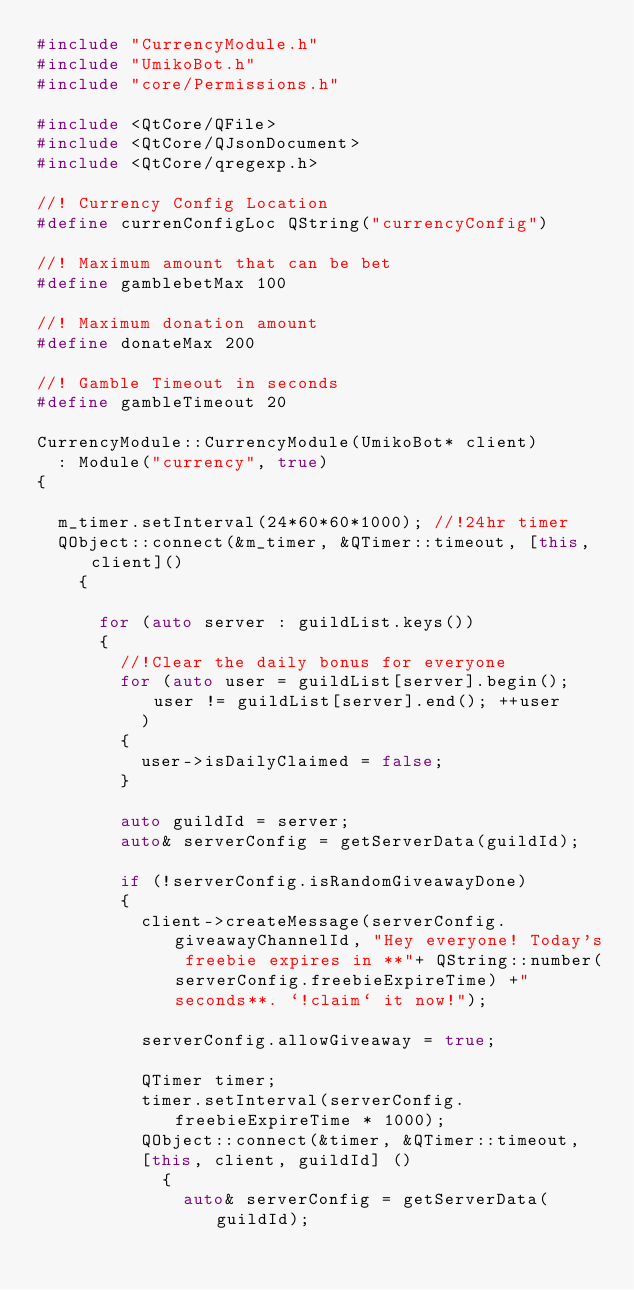<code> <loc_0><loc_0><loc_500><loc_500><_C++_>#include "CurrencyModule.h"
#include "UmikoBot.h"
#include "core/Permissions.h"

#include <QtCore/QFile>
#include <QtCore/QJsonDocument>
#include <QtCore/qregexp.h>

//! Currency Config Location
#define currenConfigLoc QString("currencyConfig")

//! Maximum amount that can be bet
#define gamblebetMax 100

//! Maximum donation amount
#define donateMax 200

//! Gamble Timeout in seconds
#define gambleTimeout 20

CurrencyModule::CurrencyModule(UmikoBot* client)
	: Module("currency", true)
{

	m_timer.setInterval(24*60*60*1000); //!24hr timer
	QObject::connect(&m_timer, &QTimer::timeout, [this, client]() 
		{
			
			for (auto server : guildList.keys()) 
			{
				//!Clear the daily bonus for everyone
				for (auto user = guildList[server].begin(); user != guildList[server].end(); ++user
					) 
				{
					user->isDailyClaimed = false;
				}

				auto guildId = server;
				auto& serverConfig = getServerData(guildId);

				if (!serverConfig.isRandomGiveawayDone) 
				{
					client->createMessage(serverConfig.giveawayChannelId, "Hey everyone! Today's freebie expires in **"+ QString::number(serverConfig.freebieExpireTime) +" seconds**. `!claim` it now!");

					serverConfig.allowGiveaway = true;

					QTimer timer;
					timer.setInterval(serverConfig.freebieExpireTime * 1000);
					QObject::connect(&timer, &QTimer::timeout, 
					[this, client, guildId] ()
						{
							auto& serverConfig = getServerData(guildId);</code> 